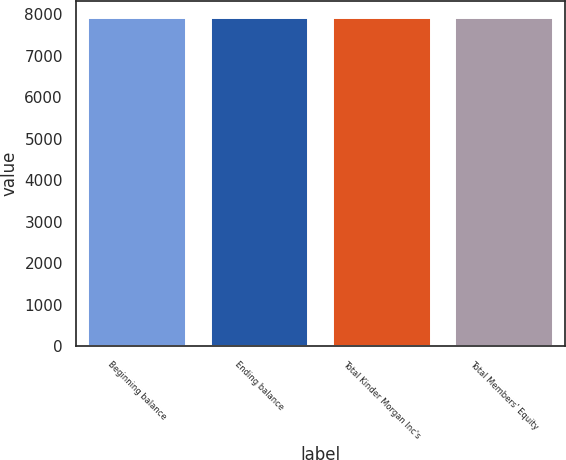Convert chart. <chart><loc_0><loc_0><loc_500><loc_500><bar_chart><fcel>Beginning balance<fcel>Ending balance<fcel>Total Kinder Morgan Inc's<fcel>Total Members' Equity<nl><fcel>7914.4<fcel>7914.5<fcel>7914.6<fcel>7914.7<nl></chart> 